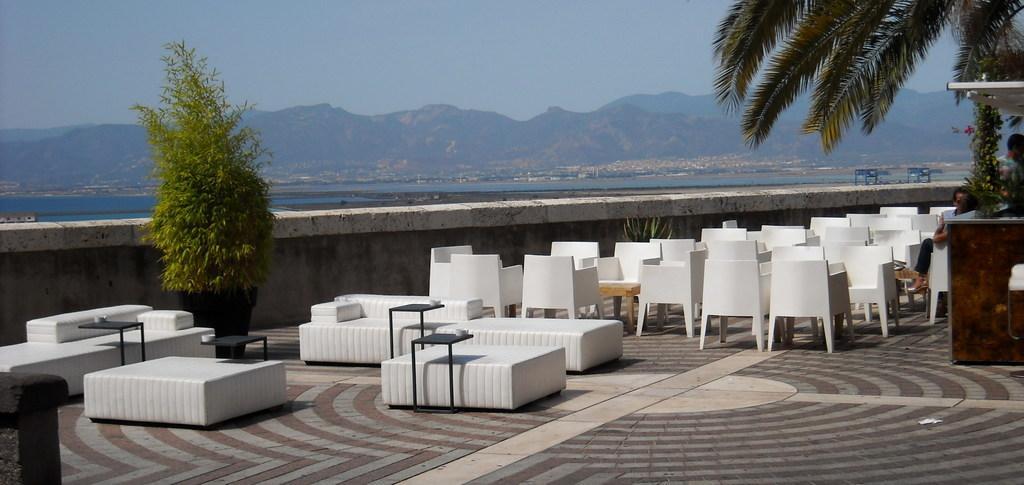In one or two sentences, can you explain what this image depicts? Completely an outdoor picture. Far there are mountains. This is a freshwater river. We can able to see number of chairs and tables. These are plants. These persons are sitting on chair. 